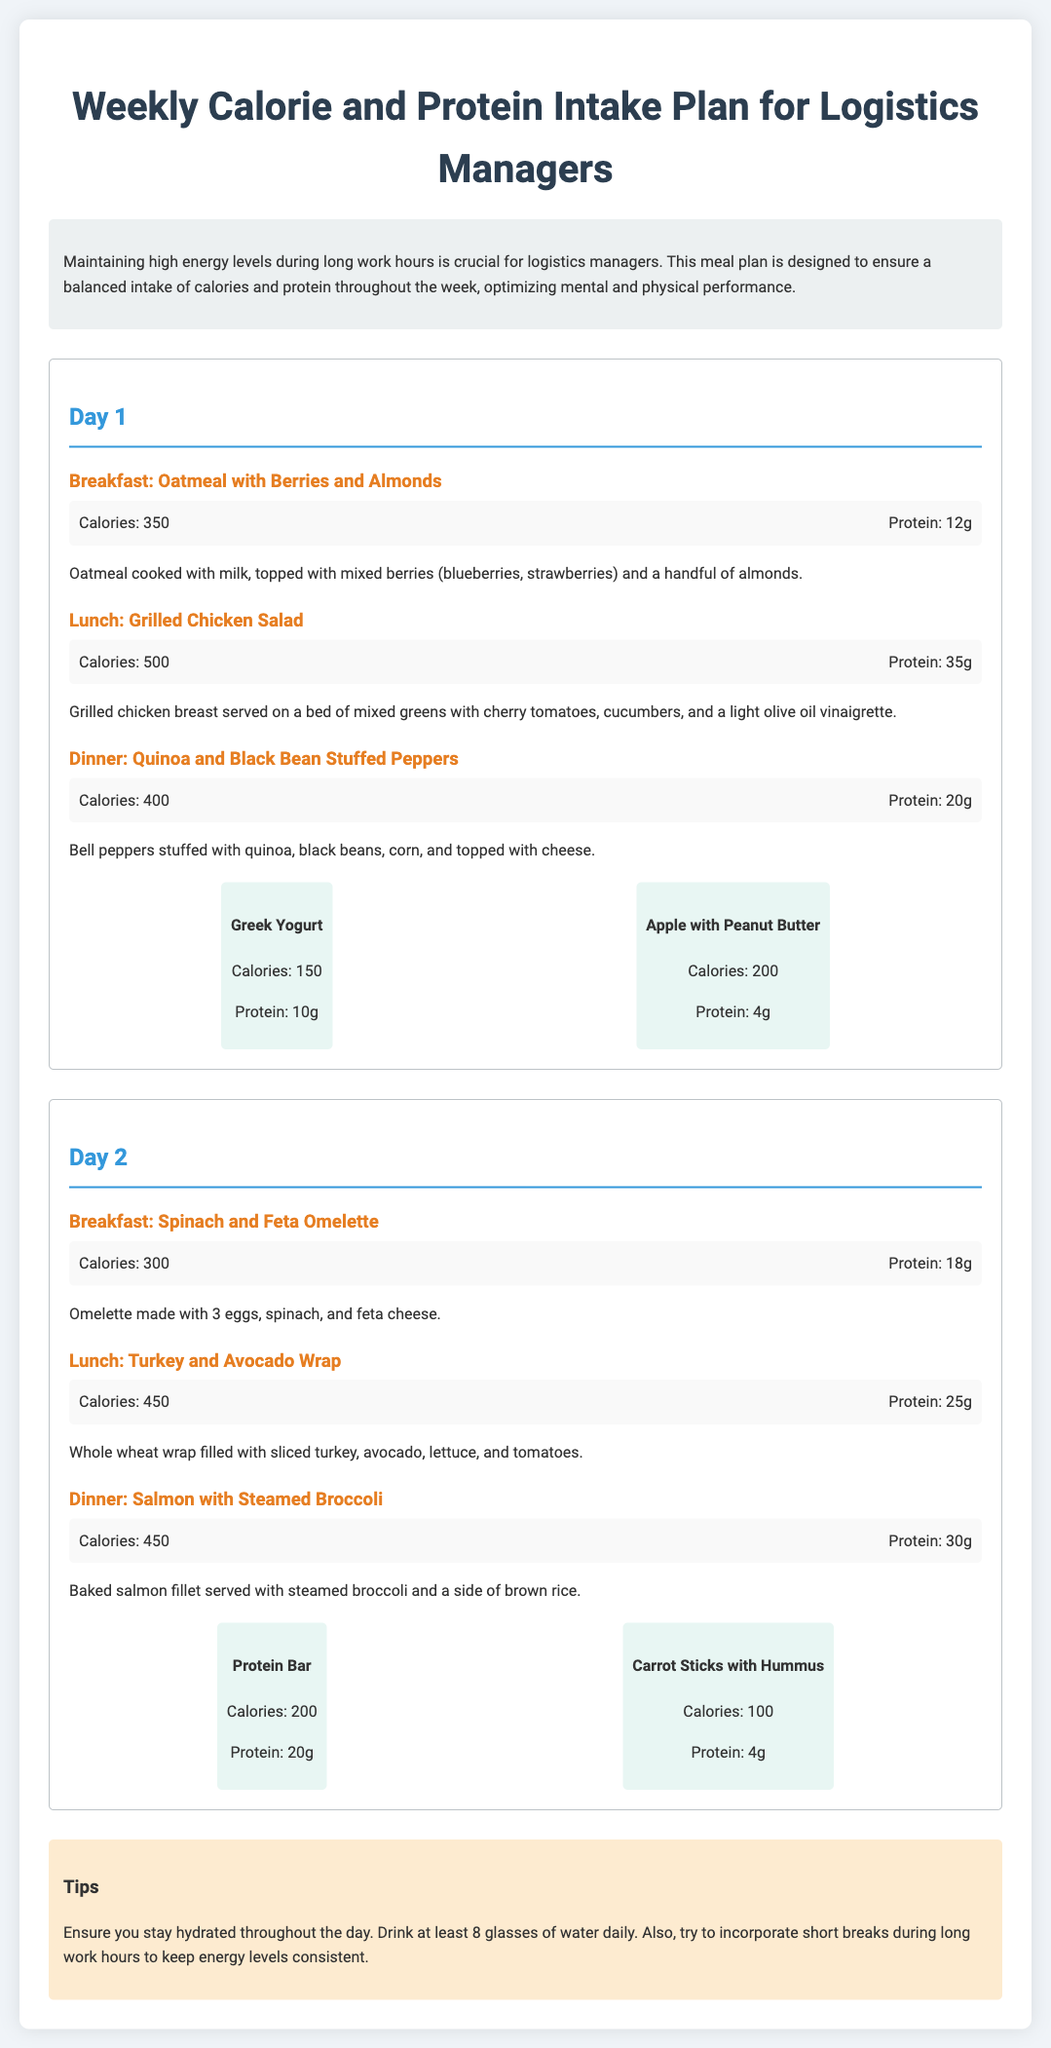What are the total calories for Day 1? To find the total calories for Day 1, we add the calories from breakfast, lunch, dinner, and snacks. That is 350 + 500 + 400 + 150 + 200 = 1600.
Answer: 1600 How much protein is in the Spinach and Feta Omelette? The protein content is listed in the meal details for the Spinach and Feta Omelette, which is 18g.
Answer: 18g What is the main ingredient in the Grilled Chicken Salad? The main ingredient in the Grilled Chicken Salad is grilled chicken breast, as stated in the meal description.
Answer: Grilled chicken breast How many calories does the Protein Bar contain? The calories for the Protein Bar are specified directly in the snack details, which are 200 calories.
Answer: 200 What meal has the highest protein intake on Day 2? To find this, we compare the protein sizes for meals on Day 2: 18g (breakfast), 25g (lunch), and 30g (dinner), with dinner having the highest at 30g.
Answer: 30g What is a suggested hydration recommendation in the tips? The tips section suggests to drink at least 8 glasses of water daily for staying hydrated.
Answer: 8 glasses What dish is served for dinner on Day 1? The document describes the dinner for Day 1 as Quinoa and Black Bean Stuffed Peppers.
Answer: Quinoa and Black Bean Stuffed Peppers What type of breakfast is recommended on Day 2? The breakfast recommended on Day 2 is Spinach and Feta Omelette, as indicated in the meal section.
Answer: Spinach and Feta Omelette 